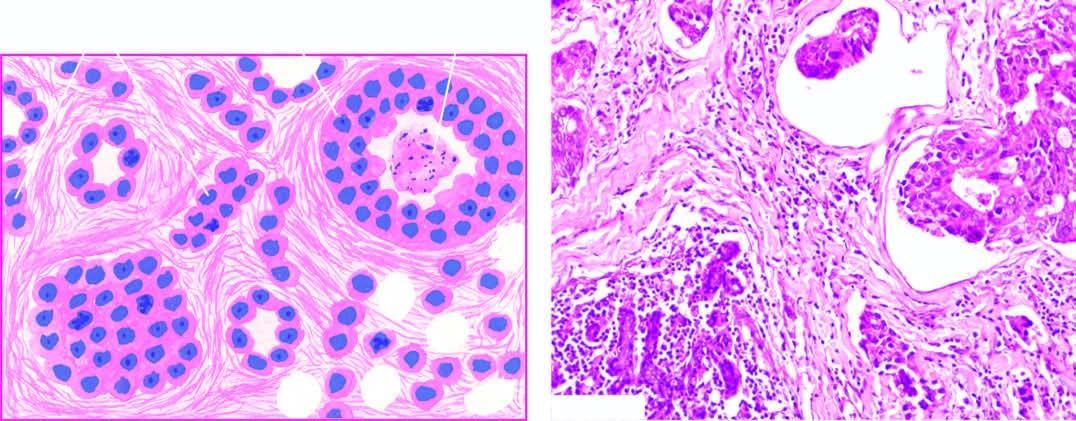do microscopic features include formation of solid nests, cords, gland-like structures and intraductal growth pattern of anaplastic tumour cells?
Answer the question using a single word or phrase. Yes 